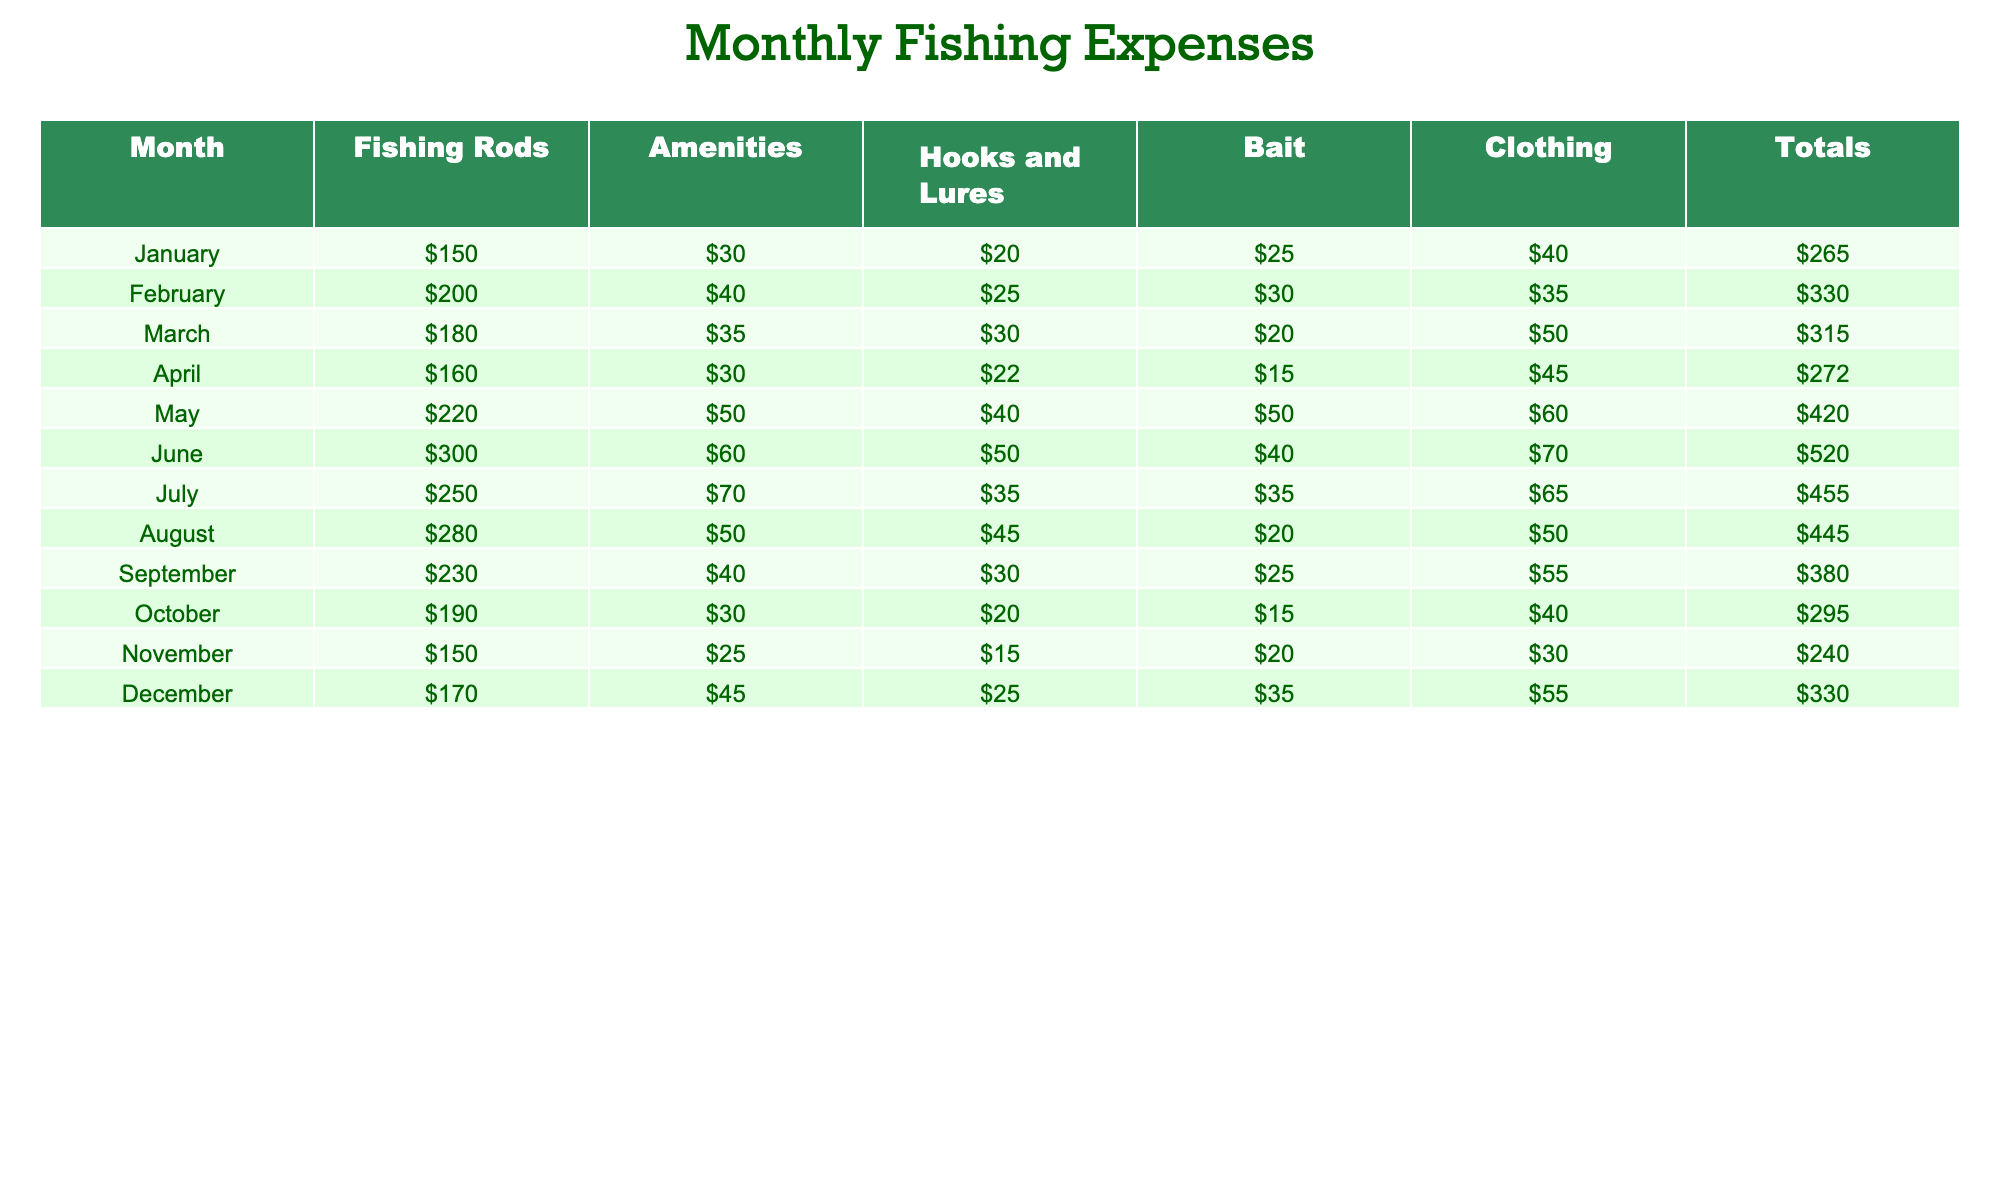What was the total expense in June? In June, the total expense listed in the table is 520.
Answer: 520 Which month had the highest expense for clothing? Looking at the clothing expenses, May has the highest amount at 60.
Answer: 60 What was the average spending on hooks and lures over the year? Adding the monthly hooks and lures expenses (20 + 25 + 30 + 22 + 40 + 50 + 35 + 45 + 30 + 20 + 15 + 25 = 432) gives a total of 432. There are 12 months, so the average is 432/12 = 36.
Answer: 36 Did the total expenses for July exceed those for November? The total expense for July is 455, and for November is 240. Since 455 is greater than 240, the statement is true.
Answer: Yes What was the increase in total expenses from January to May? The total expense in January is 265, and in May it is 420. The increase is calculated as 420 - 265 = 155.
Answer: 155 What is the month with the lowest expense on amenities, and what was the amount? Looking through the amenities column, November has the lowest expense at 25.
Answer: November, 25 How much more did we spend on fishing rods in August compared to April? The expense on fishing rods in August is 280, and in April it is 160. The difference is 280 - 160 = 120.
Answer: 120 What was the total expense across all months for Bait? Adding the bait expenses gives us (25 + 30 + 20 + 15 + 50 + 40 + 35 + 20 + 25 + 15 + 20 + 35 = 300).
Answer: 300 Which month had the highest total expense and what was that expense? June had the highest total expense of 520.
Answer: June, 520 If we combine the expenses for Fishing Rods and Bait in September, what is the total? In September, the Fishing Rods expense is 230 and Bait is 25. Adding these gives 230 + 25 = 255.
Answer: 255 